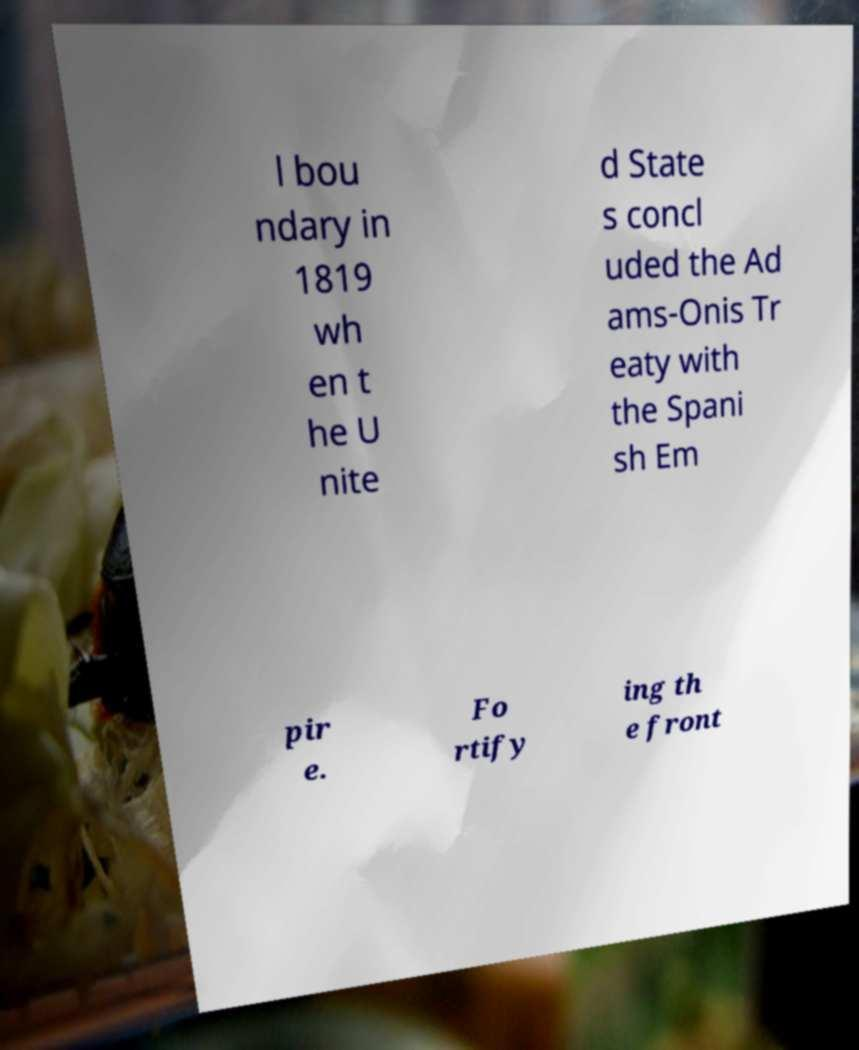Please read and relay the text visible in this image. What does it say? l bou ndary in 1819 wh en t he U nite d State s concl uded the Ad ams-Onis Tr eaty with the Spani sh Em pir e. Fo rtify ing th e front 